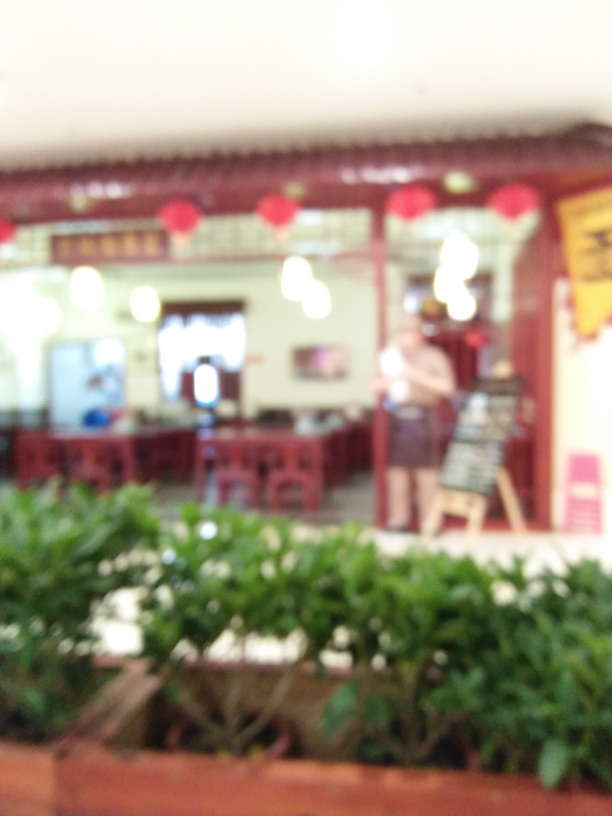Can you describe the setting of this image? Given the blurriness of the image, it's difficult to discern the specifics, but it seems to be an indoor setting with some greenery in the foreground. Red lanterns suggest an Asian theme, potentially a restaurant or a social gathering place. What does the blur say about the photo? The blur could indicate a swift movement during the shot or a focus issue with the camera. It adds a mysterious or dreamlike quality to the photo, leaving much to the imagination about the exact details of the scene. 